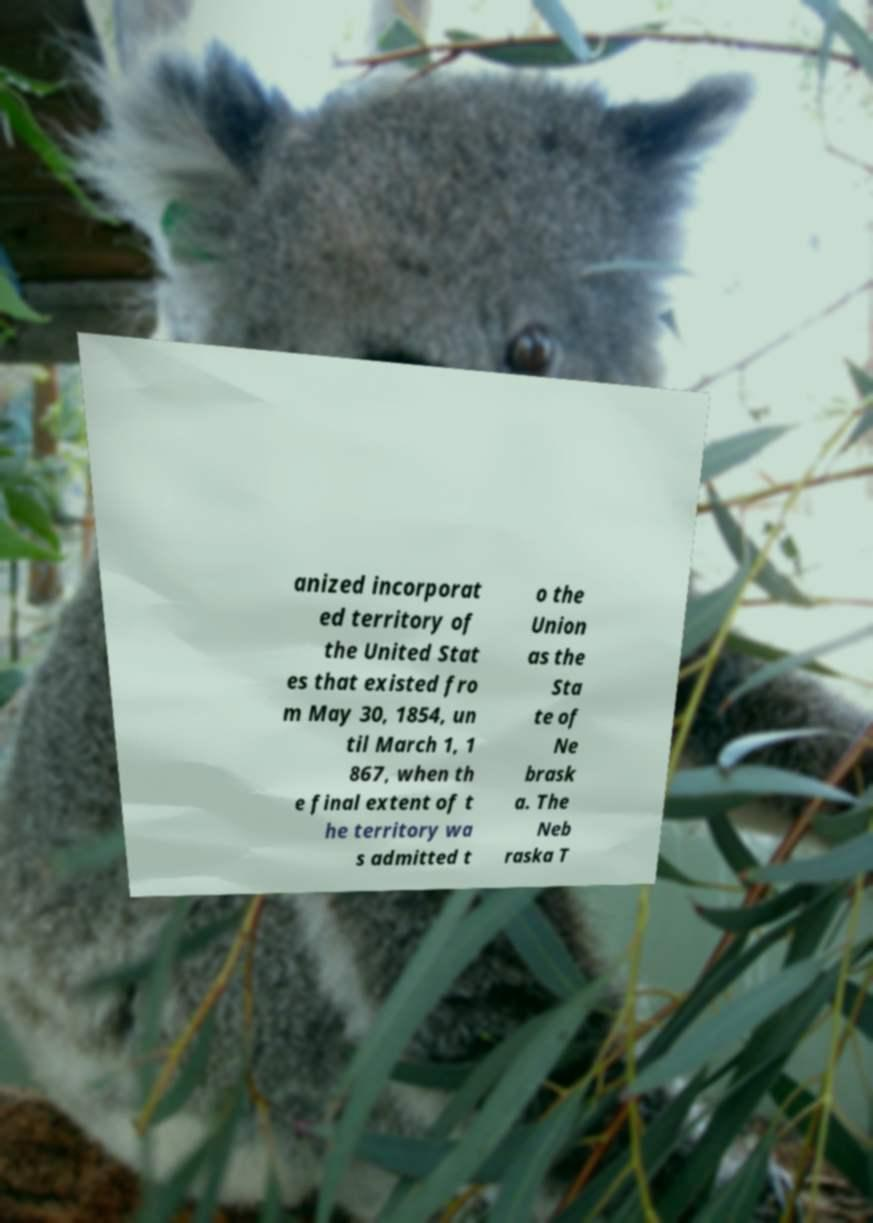What messages or text are displayed in this image? I need them in a readable, typed format. anized incorporat ed territory of the United Stat es that existed fro m May 30, 1854, un til March 1, 1 867, when th e final extent of t he territory wa s admitted t o the Union as the Sta te of Ne brask a. The Neb raska T 